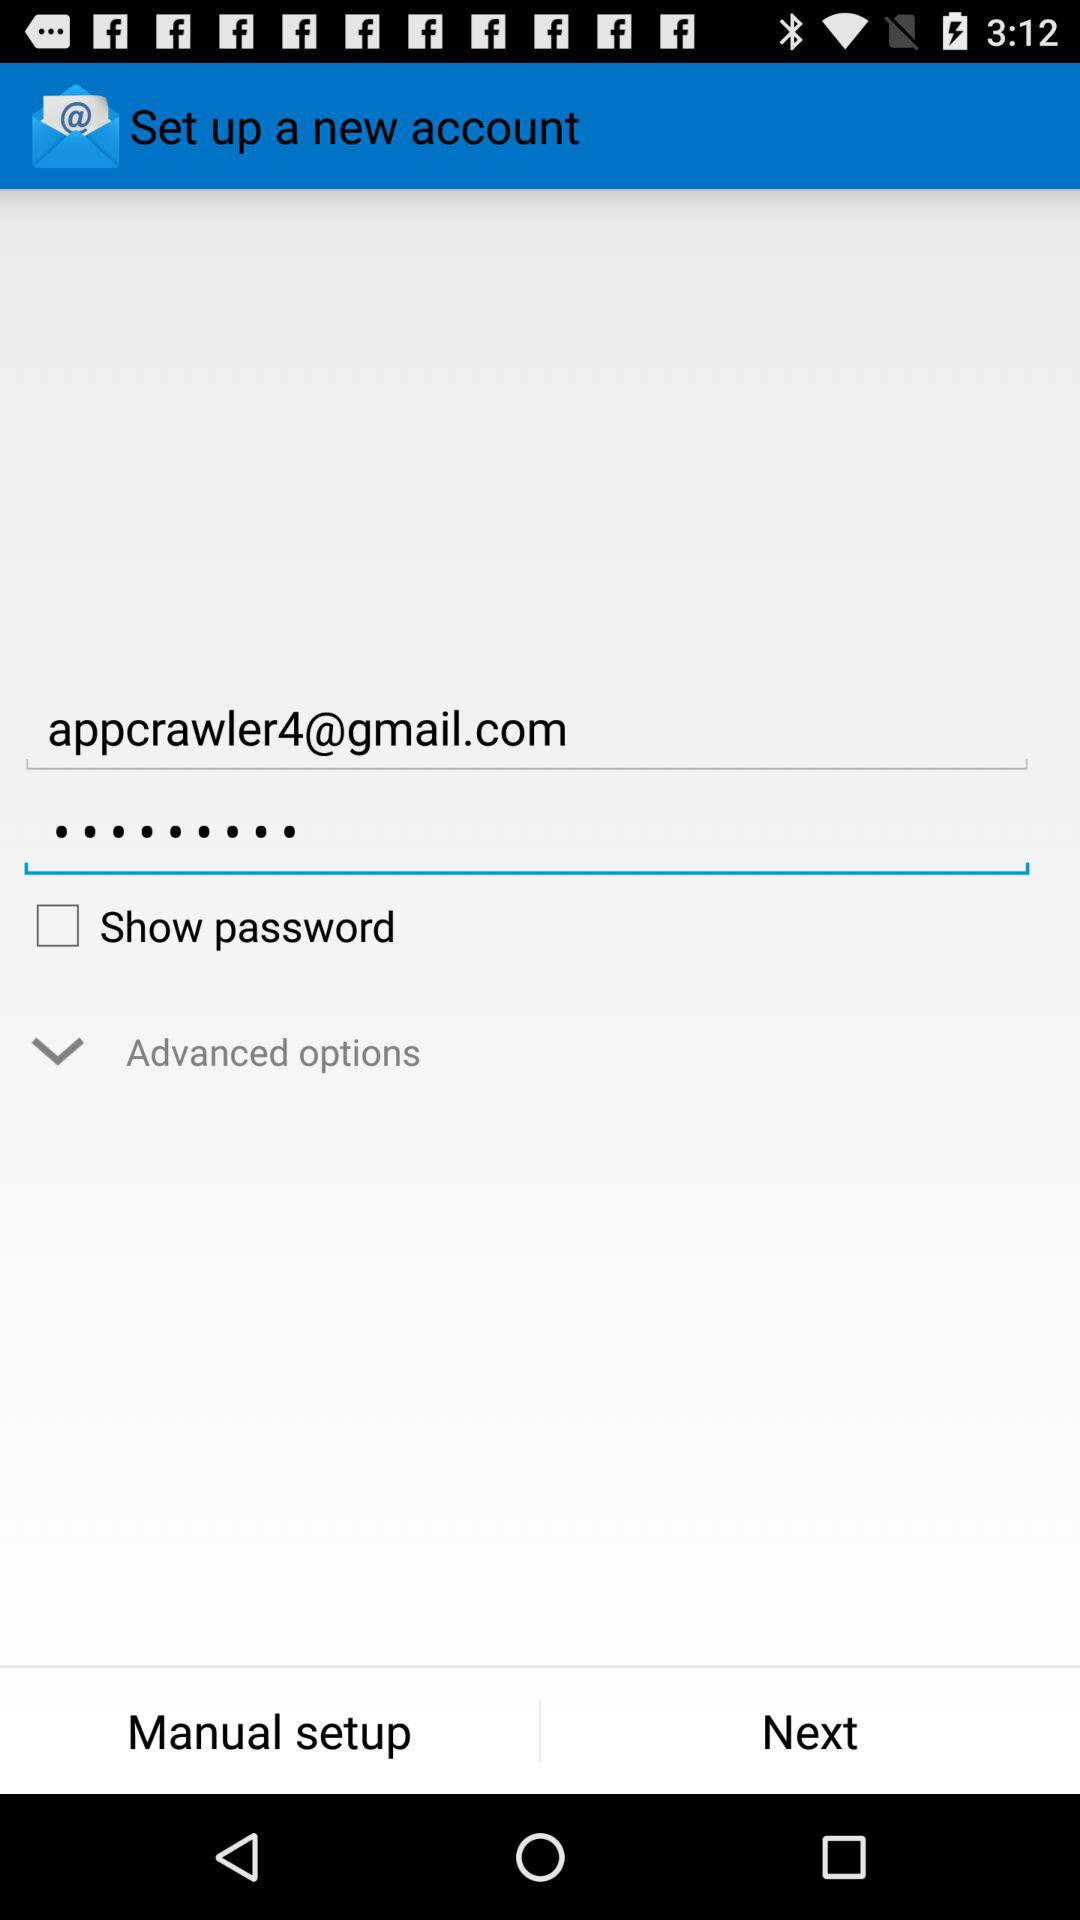What is the given email ID? The given email ID is appcrawler4@gmail.com. 